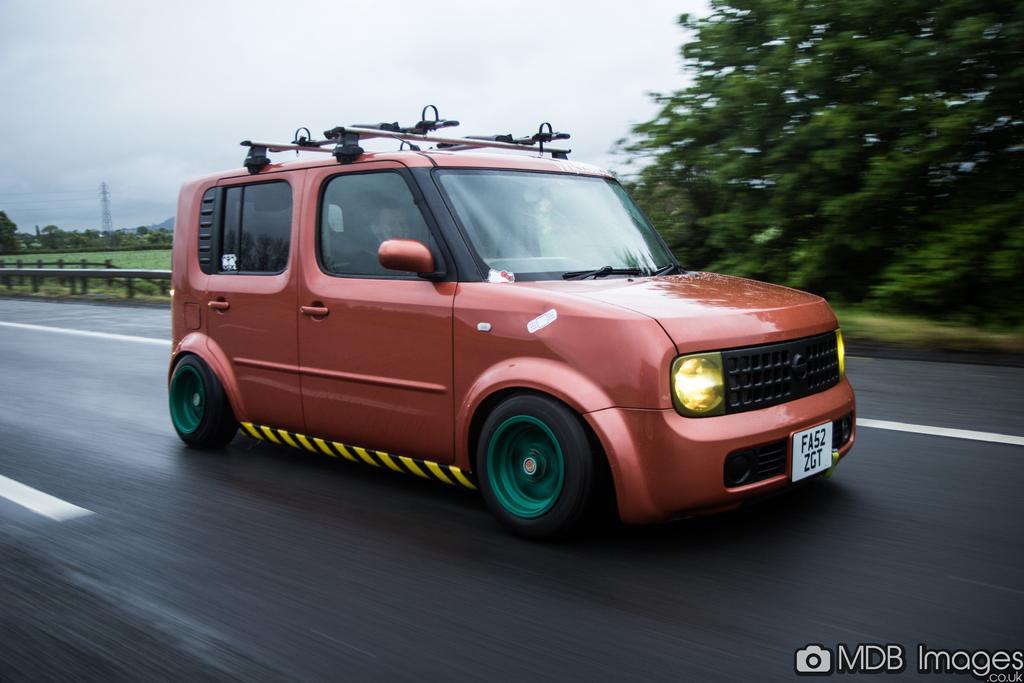How would you summarize this image in a sentence or two? In this image in the middle there is a car. At the bottom there is a text and a road. In the background there are trees, tower, cables, grass, hill, sky and clouds. 